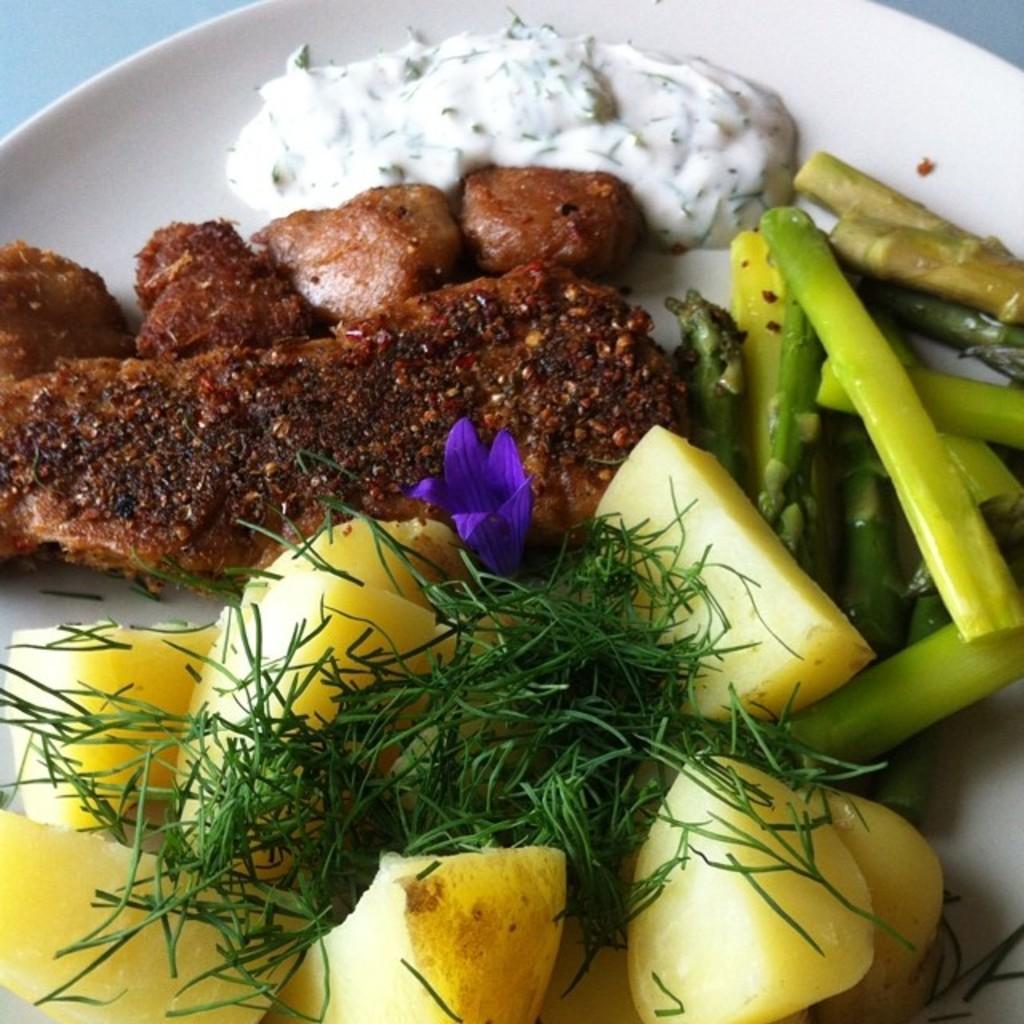Could you give a brief overview of what you see in this image? In this image we can see some food items and a flower in the plate. In the background of the image there is a white background. 